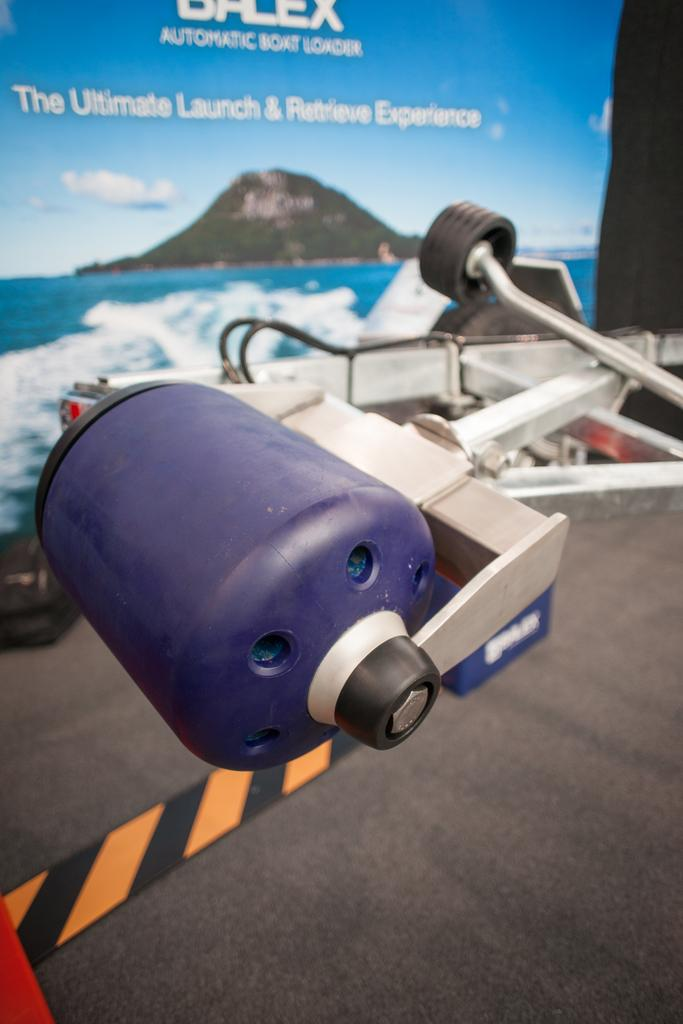What type of object is present in the image? There is a metal object in the image. What is visible at the bottom of the image? There is a floor visible at the bottom of the image. What can be seen in the background of the image? There is a big banner in the background of the image. How does the metal object participate in the disgusting aftermath of the observation? The metal object does not participate in any disgusting aftermath, as there is no such event or situation depicted in the image. 